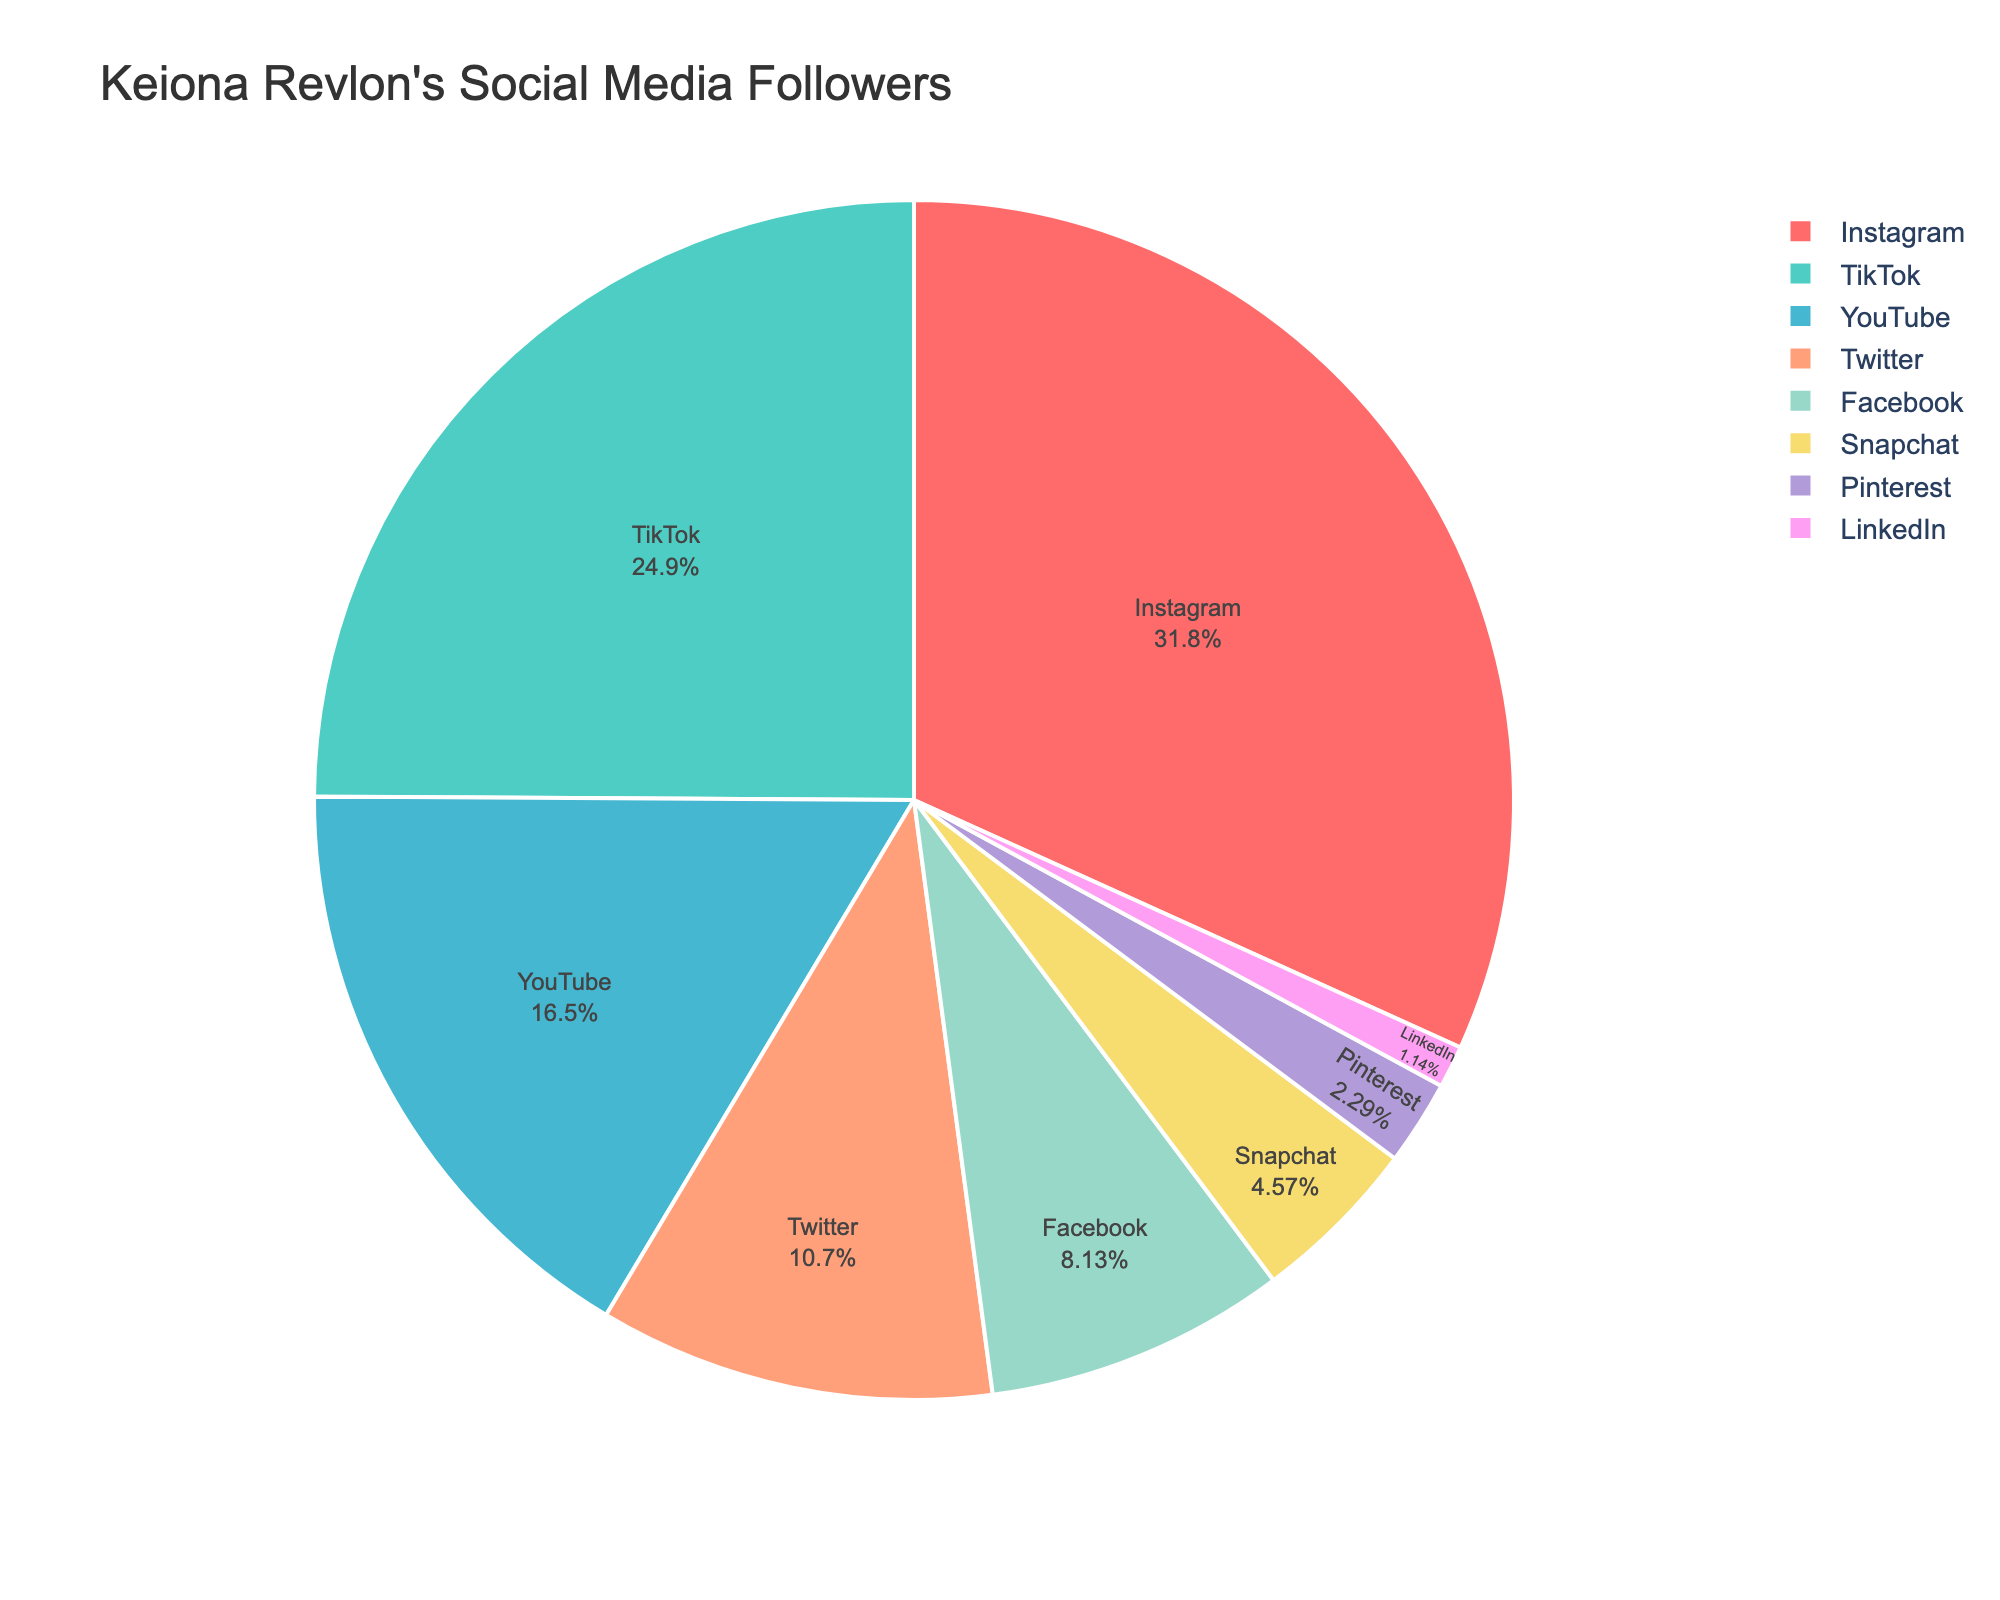Which platform has the largest number of followers? By looking at the pie chart, the platform with the biggest slice represents the largest number of followers.
Answer: Instagram What percentage of Keiona Revlon's followers are on TikTok? Observe the label inside the TikTok section of the pie chart, which shows both the percentage and the platform name.
Answer: 30.9% Which two platforms combined have the smallest share of followers? Identify the two smallest slices on the pie chart and sum their respective percentages.
Answer: LinkedIn and Pinterest Is the number of followers on YouTube greater than on Facebook and Twitter combined? Compare the labels on the YouTube slice to the combined total of the Facebook and Twitter slices. YouTube has 650,000 followers while the sum of Facebook and Twitter is 740,000 (320,000 + 420,000).
Answer: No What's the total number of followers across all platforms? Add up the follower counts for all the platforms: 1,250,000 + 980,000 + 650,000 + 420,000 + 320,000 + 180,000 + 90,000 + 45,000.
Answer: 3,935,000 How many platforms have at least 15% of the total followers? Identify the slices with percentage labels showing 15% or more and count them. Instagram and TikTok are above 15%.
Answer: 2 Which platform has approximately 4.6% of the total followers? Find the slice with the label showing approximately 4.6%; this corresponds to Snapchat.
Answer: Snapchat Is the number of followers on LinkedIn closer to Pinterest or Snapchat? Compare LinkedIn (45,000) to Pinterest (90,000) and Snapchat (180,000). The difference is 45,000 with Pinterest and 135,000 with Snapchat, making it closer to Pinterest.
Answer: Pinterest What's the difference in followers between Instagram and Twitter? Subtract the number of Twitter followers from Instagram followers: 1,250,000 - 420,000.
Answer: 830,000 Which platform, displayed in bluish color, has the highest number of followers? Identify the slice with a bluish color (excluding shades like teal) and those platforms are Instagram and YouTube. Instagram among them has the highest followers.
Answer: Instagram 